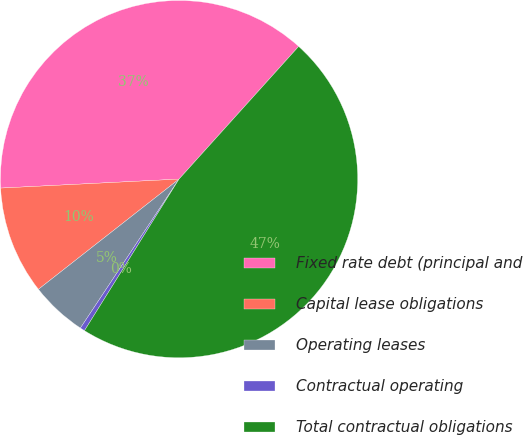Convert chart. <chart><loc_0><loc_0><loc_500><loc_500><pie_chart><fcel>Fixed rate debt (principal and<fcel>Capital lease obligations<fcel>Operating leases<fcel>Contractual operating<fcel>Total contractual obligations<nl><fcel>37.48%<fcel>9.78%<fcel>5.11%<fcel>0.43%<fcel>47.2%<nl></chart> 